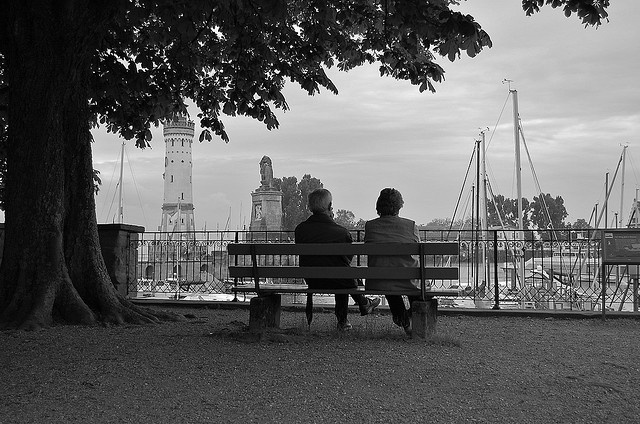Describe the objects in this image and their specific colors. I can see bench in black, gray, darkgray, and lightgray tones, people in black, gray, darkgray, and lightgray tones, people in black, gray, darkgray, and lightgray tones, boat in black, darkgray, gray, and lightgray tones, and boat in black, darkgray, gray, and lightgray tones in this image. 